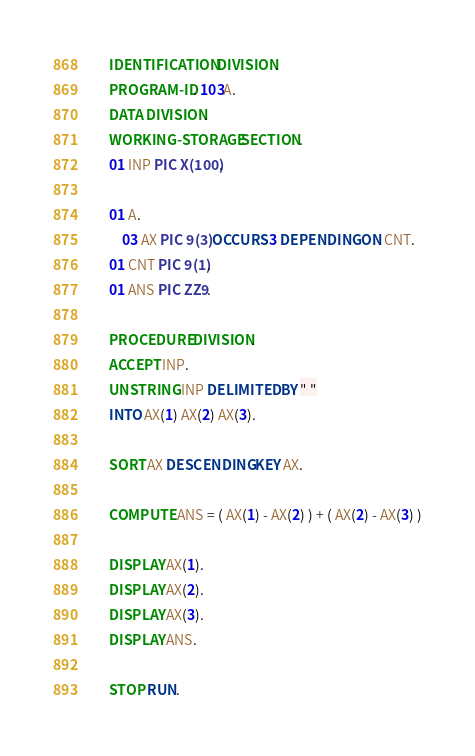<code> <loc_0><loc_0><loc_500><loc_500><_COBOL_>      IDENTIFICATION DIVISION.
      PROGRAM-ID. 103A.
      DATA DIVISION.
      WORKING-STORAGE SECTION.
      01 INP PIC X(100).
      
      01 A.
      	03 AX PIC 9(3) OCCURS 3 DEPENDING ON CNT.
      01 CNT PIC 9(1).
      01 ANS PIC ZZ9.
      
      PROCEDURE DIVISION.
      ACCEPT INP.      
      UNSTRING INP DELIMITED BY " "
      INTO AX(1) AX(2) AX(3).
      
      SORT AX DESCENDING KEY AX.
      
      COMPUTE ANS = ( AX(1) - AX(2) ) + ( AX(2) - AX(3) )

      DISPLAY AX(1).
      DISPLAY AX(2).
      DISPLAY AX(3).
      DISPLAY ANS.
      
      STOP RUN.
</code> 